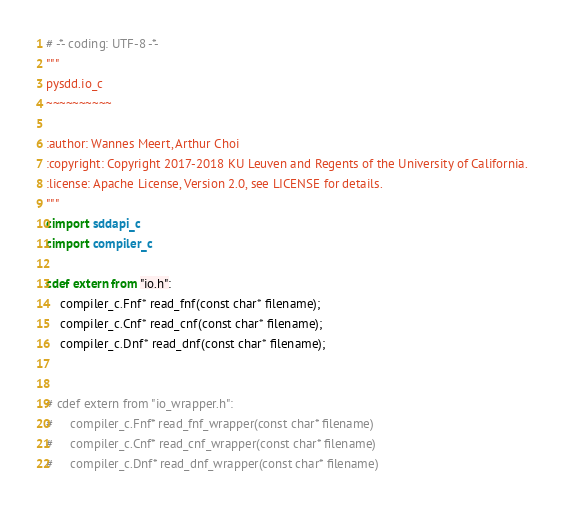<code> <loc_0><loc_0><loc_500><loc_500><_Cython_># -*- coding: UTF-8 -*-
"""
pysdd.io_c
~~~~~~~~~~

:author: Wannes Meert, Arthur Choi
:copyright: Copyright 2017-2018 KU Leuven and Regents of the University of California.
:license: Apache License, Version 2.0, see LICENSE for details.
"""
cimport sddapi_c
cimport compiler_c

cdef extern from "io.h":
    compiler_c.Fnf* read_fnf(const char* filename);
    compiler_c.Cnf* read_cnf(const char* filename);
    compiler_c.Dnf* read_dnf(const char* filename);


# cdef extern from "io_wrapper.h":
#     compiler_c.Fnf* read_fnf_wrapper(const char* filename)
#     compiler_c.Cnf* read_cnf_wrapper(const char* filename)
#     compiler_c.Dnf* read_dnf_wrapper(const char* filename)
</code> 